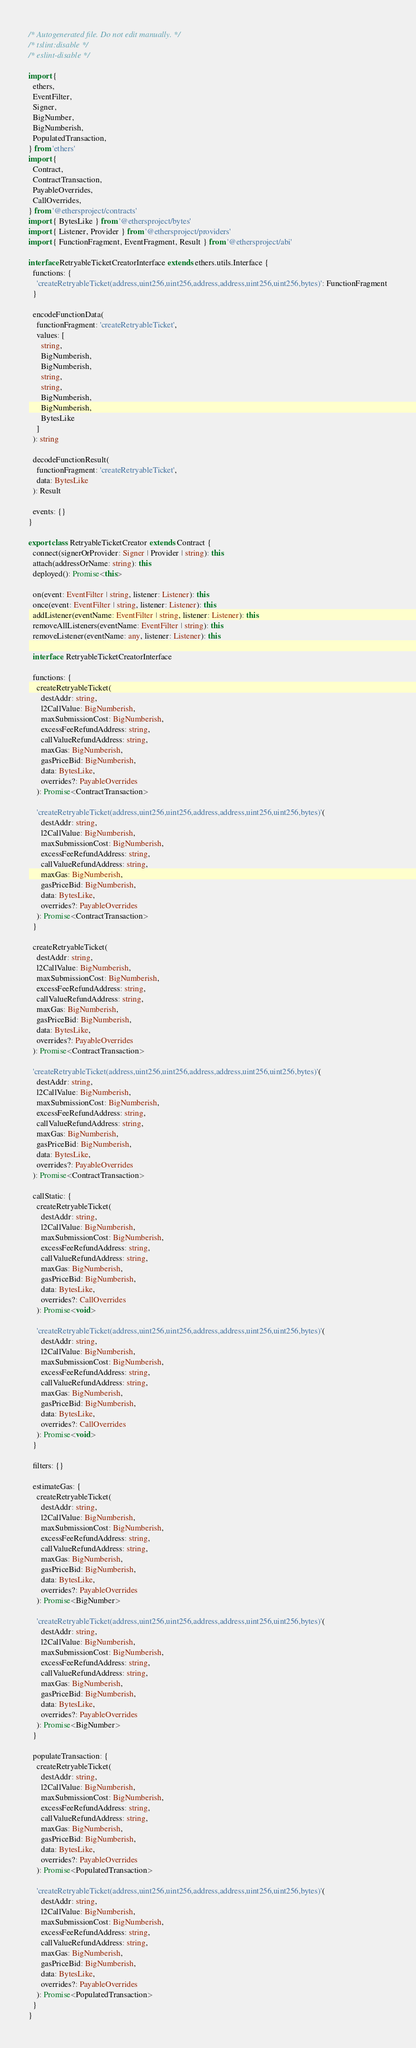<code> <loc_0><loc_0><loc_500><loc_500><_TypeScript_>/* Autogenerated file. Do not edit manually. */
/* tslint:disable */
/* eslint-disable */

import {
  ethers,
  EventFilter,
  Signer,
  BigNumber,
  BigNumberish,
  PopulatedTransaction,
} from 'ethers'
import {
  Contract,
  ContractTransaction,
  PayableOverrides,
  CallOverrides,
} from '@ethersproject/contracts'
import { BytesLike } from '@ethersproject/bytes'
import { Listener, Provider } from '@ethersproject/providers'
import { FunctionFragment, EventFragment, Result } from '@ethersproject/abi'

interface RetryableTicketCreatorInterface extends ethers.utils.Interface {
  functions: {
    'createRetryableTicket(address,uint256,uint256,address,address,uint256,uint256,bytes)': FunctionFragment
  }

  encodeFunctionData(
    functionFragment: 'createRetryableTicket',
    values: [
      string,
      BigNumberish,
      BigNumberish,
      string,
      string,
      BigNumberish,
      BigNumberish,
      BytesLike
    ]
  ): string

  decodeFunctionResult(
    functionFragment: 'createRetryableTicket',
    data: BytesLike
  ): Result

  events: {}
}

export class RetryableTicketCreator extends Contract {
  connect(signerOrProvider: Signer | Provider | string): this
  attach(addressOrName: string): this
  deployed(): Promise<this>

  on(event: EventFilter | string, listener: Listener): this
  once(event: EventFilter | string, listener: Listener): this
  addListener(eventName: EventFilter | string, listener: Listener): this
  removeAllListeners(eventName: EventFilter | string): this
  removeListener(eventName: any, listener: Listener): this

  interface: RetryableTicketCreatorInterface

  functions: {
    createRetryableTicket(
      destAddr: string,
      l2CallValue: BigNumberish,
      maxSubmissionCost: BigNumberish,
      excessFeeRefundAddress: string,
      callValueRefundAddress: string,
      maxGas: BigNumberish,
      gasPriceBid: BigNumberish,
      data: BytesLike,
      overrides?: PayableOverrides
    ): Promise<ContractTransaction>

    'createRetryableTicket(address,uint256,uint256,address,address,uint256,uint256,bytes)'(
      destAddr: string,
      l2CallValue: BigNumberish,
      maxSubmissionCost: BigNumberish,
      excessFeeRefundAddress: string,
      callValueRefundAddress: string,
      maxGas: BigNumberish,
      gasPriceBid: BigNumberish,
      data: BytesLike,
      overrides?: PayableOverrides
    ): Promise<ContractTransaction>
  }

  createRetryableTicket(
    destAddr: string,
    l2CallValue: BigNumberish,
    maxSubmissionCost: BigNumberish,
    excessFeeRefundAddress: string,
    callValueRefundAddress: string,
    maxGas: BigNumberish,
    gasPriceBid: BigNumberish,
    data: BytesLike,
    overrides?: PayableOverrides
  ): Promise<ContractTransaction>

  'createRetryableTicket(address,uint256,uint256,address,address,uint256,uint256,bytes)'(
    destAddr: string,
    l2CallValue: BigNumberish,
    maxSubmissionCost: BigNumberish,
    excessFeeRefundAddress: string,
    callValueRefundAddress: string,
    maxGas: BigNumberish,
    gasPriceBid: BigNumberish,
    data: BytesLike,
    overrides?: PayableOverrides
  ): Promise<ContractTransaction>

  callStatic: {
    createRetryableTicket(
      destAddr: string,
      l2CallValue: BigNumberish,
      maxSubmissionCost: BigNumberish,
      excessFeeRefundAddress: string,
      callValueRefundAddress: string,
      maxGas: BigNumberish,
      gasPriceBid: BigNumberish,
      data: BytesLike,
      overrides?: CallOverrides
    ): Promise<void>

    'createRetryableTicket(address,uint256,uint256,address,address,uint256,uint256,bytes)'(
      destAddr: string,
      l2CallValue: BigNumberish,
      maxSubmissionCost: BigNumberish,
      excessFeeRefundAddress: string,
      callValueRefundAddress: string,
      maxGas: BigNumberish,
      gasPriceBid: BigNumberish,
      data: BytesLike,
      overrides?: CallOverrides
    ): Promise<void>
  }

  filters: {}

  estimateGas: {
    createRetryableTicket(
      destAddr: string,
      l2CallValue: BigNumberish,
      maxSubmissionCost: BigNumberish,
      excessFeeRefundAddress: string,
      callValueRefundAddress: string,
      maxGas: BigNumberish,
      gasPriceBid: BigNumberish,
      data: BytesLike,
      overrides?: PayableOverrides
    ): Promise<BigNumber>

    'createRetryableTicket(address,uint256,uint256,address,address,uint256,uint256,bytes)'(
      destAddr: string,
      l2CallValue: BigNumberish,
      maxSubmissionCost: BigNumberish,
      excessFeeRefundAddress: string,
      callValueRefundAddress: string,
      maxGas: BigNumberish,
      gasPriceBid: BigNumberish,
      data: BytesLike,
      overrides?: PayableOverrides
    ): Promise<BigNumber>
  }

  populateTransaction: {
    createRetryableTicket(
      destAddr: string,
      l2CallValue: BigNumberish,
      maxSubmissionCost: BigNumberish,
      excessFeeRefundAddress: string,
      callValueRefundAddress: string,
      maxGas: BigNumberish,
      gasPriceBid: BigNumberish,
      data: BytesLike,
      overrides?: PayableOverrides
    ): Promise<PopulatedTransaction>

    'createRetryableTicket(address,uint256,uint256,address,address,uint256,uint256,bytes)'(
      destAddr: string,
      l2CallValue: BigNumberish,
      maxSubmissionCost: BigNumberish,
      excessFeeRefundAddress: string,
      callValueRefundAddress: string,
      maxGas: BigNumberish,
      gasPriceBid: BigNumberish,
      data: BytesLike,
      overrides?: PayableOverrides
    ): Promise<PopulatedTransaction>
  }
}
</code> 